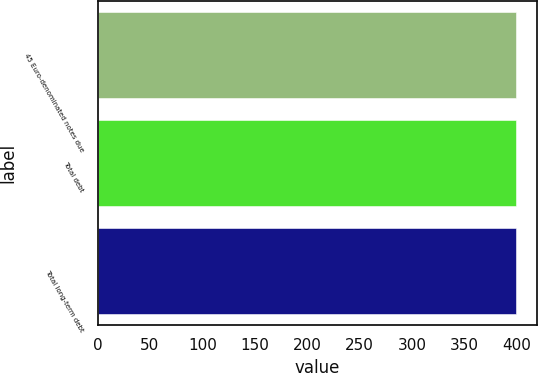Convert chart. <chart><loc_0><loc_0><loc_500><loc_500><bar_chart><fcel>45 Euro-denominated notes due<fcel>Total debt<fcel>Total long-term debt<nl><fcel>398.8<fcel>398.9<fcel>399<nl></chart> 